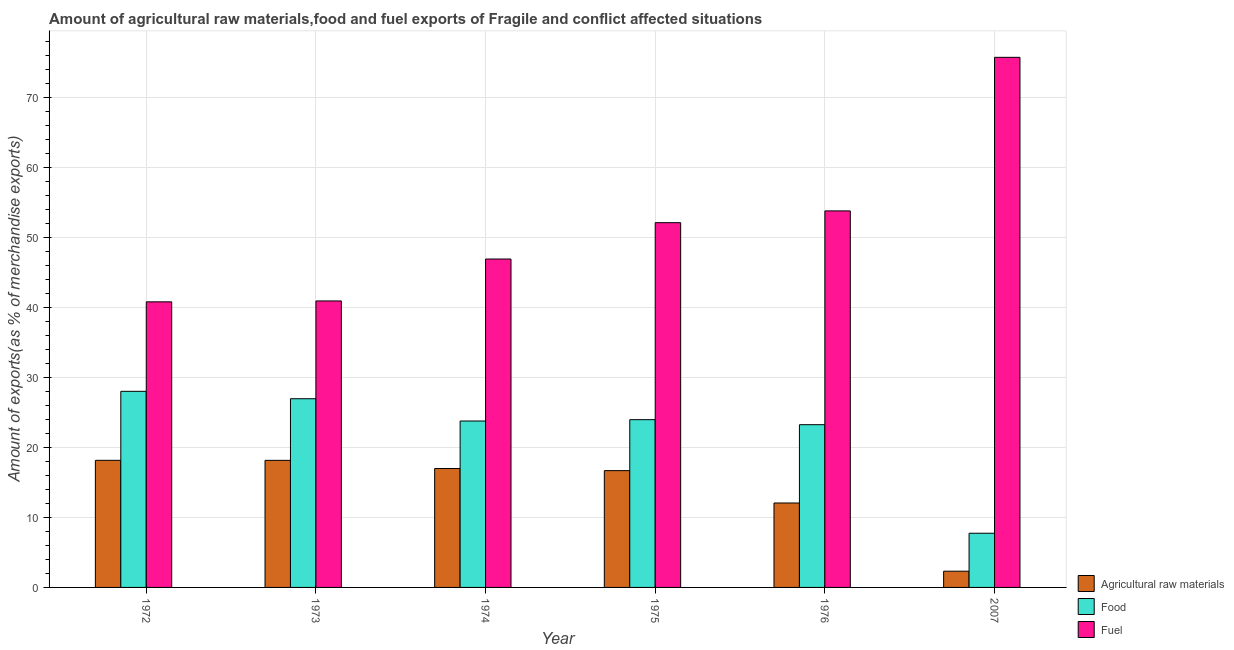How many different coloured bars are there?
Offer a terse response. 3. Are the number of bars on each tick of the X-axis equal?
Make the answer very short. Yes. How many bars are there on the 1st tick from the right?
Your answer should be very brief. 3. What is the label of the 5th group of bars from the left?
Provide a succinct answer. 1976. What is the percentage of fuel exports in 1976?
Provide a succinct answer. 53.82. Across all years, what is the maximum percentage of fuel exports?
Ensure brevity in your answer.  75.77. Across all years, what is the minimum percentage of food exports?
Keep it short and to the point. 7.75. In which year was the percentage of food exports maximum?
Ensure brevity in your answer.  1972. In which year was the percentage of food exports minimum?
Your response must be concise. 2007. What is the total percentage of fuel exports in the graph?
Keep it short and to the point. 310.43. What is the difference between the percentage of fuel exports in 1973 and that in 1975?
Your response must be concise. -11.19. What is the difference between the percentage of food exports in 1972 and the percentage of raw materials exports in 1976?
Provide a short and direct response. 4.77. What is the average percentage of raw materials exports per year?
Keep it short and to the point. 14.07. In the year 1974, what is the difference between the percentage of food exports and percentage of fuel exports?
Offer a very short reply. 0. In how many years, is the percentage of food exports greater than 52 %?
Ensure brevity in your answer.  0. What is the ratio of the percentage of raw materials exports in 1973 to that in 1976?
Provide a succinct answer. 1.51. Is the percentage of raw materials exports in 1975 less than that in 2007?
Your answer should be compact. No. What is the difference between the highest and the second highest percentage of food exports?
Your answer should be very brief. 1.06. What is the difference between the highest and the lowest percentage of food exports?
Your answer should be very brief. 20.29. What does the 1st bar from the left in 1974 represents?
Your response must be concise. Agricultural raw materials. What does the 1st bar from the right in 1973 represents?
Provide a short and direct response. Fuel. Are all the bars in the graph horizontal?
Offer a very short reply. No. Are the values on the major ticks of Y-axis written in scientific E-notation?
Ensure brevity in your answer.  No. Does the graph contain any zero values?
Make the answer very short. No. How many legend labels are there?
Ensure brevity in your answer.  3. How are the legend labels stacked?
Make the answer very short. Vertical. What is the title of the graph?
Ensure brevity in your answer.  Amount of agricultural raw materials,food and fuel exports of Fragile and conflict affected situations. What is the label or title of the X-axis?
Keep it short and to the point. Year. What is the label or title of the Y-axis?
Give a very brief answer. Amount of exports(as % of merchandise exports). What is the Amount of exports(as % of merchandise exports) of Agricultural raw materials in 1972?
Give a very brief answer. 18.17. What is the Amount of exports(as % of merchandise exports) in Food in 1972?
Offer a very short reply. 28.03. What is the Amount of exports(as % of merchandise exports) in Fuel in 1972?
Offer a very short reply. 40.82. What is the Amount of exports(as % of merchandise exports) in Agricultural raw materials in 1973?
Make the answer very short. 18.16. What is the Amount of exports(as % of merchandise exports) in Food in 1973?
Keep it short and to the point. 26.97. What is the Amount of exports(as % of merchandise exports) in Fuel in 1973?
Ensure brevity in your answer.  40.95. What is the Amount of exports(as % of merchandise exports) of Agricultural raw materials in 1974?
Ensure brevity in your answer.  17. What is the Amount of exports(as % of merchandise exports) of Food in 1974?
Provide a short and direct response. 23.79. What is the Amount of exports(as % of merchandise exports) in Fuel in 1974?
Your answer should be compact. 46.94. What is the Amount of exports(as % of merchandise exports) in Agricultural raw materials in 1975?
Provide a succinct answer. 16.69. What is the Amount of exports(as % of merchandise exports) of Food in 1975?
Provide a short and direct response. 23.98. What is the Amount of exports(as % of merchandise exports) in Fuel in 1975?
Give a very brief answer. 52.14. What is the Amount of exports(as % of merchandise exports) in Agricultural raw materials in 1976?
Offer a very short reply. 12.07. What is the Amount of exports(as % of merchandise exports) in Food in 1976?
Give a very brief answer. 23.26. What is the Amount of exports(as % of merchandise exports) in Fuel in 1976?
Offer a very short reply. 53.82. What is the Amount of exports(as % of merchandise exports) in Agricultural raw materials in 2007?
Keep it short and to the point. 2.32. What is the Amount of exports(as % of merchandise exports) in Food in 2007?
Give a very brief answer. 7.75. What is the Amount of exports(as % of merchandise exports) in Fuel in 2007?
Keep it short and to the point. 75.77. Across all years, what is the maximum Amount of exports(as % of merchandise exports) of Agricultural raw materials?
Your response must be concise. 18.17. Across all years, what is the maximum Amount of exports(as % of merchandise exports) in Food?
Provide a succinct answer. 28.03. Across all years, what is the maximum Amount of exports(as % of merchandise exports) in Fuel?
Your answer should be compact. 75.77. Across all years, what is the minimum Amount of exports(as % of merchandise exports) of Agricultural raw materials?
Your answer should be compact. 2.32. Across all years, what is the minimum Amount of exports(as % of merchandise exports) in Food?
Your answer should be very brief. 7.75. Across all years, what is the minimum Amount of exports(as % of merchandise exports) of Fuel?
Ensure brevity in your answer.  40.82. What is the total Amount of exports(as % of merchandise exports) of Agricultural raw materials in the graph?
Your answer should be very brief. 84.41. What is the total Amount of exports(as % of merchandise exports) in Food in the graph?
Your answer should be very brief. 133.78. What is the total Amount of exports(as % of merchandise exports) of Fuel in the graph?
Offer a very short reply. 310.43. What is the difference between the Amount of exports(as % of merchandise exports) in Agricultural raw materials in 1972 and that in 1973?
Your answer should be very brief. 0. What is the difference between the Amount of exports(as % of merchandise exports) in Food in 1972 and that in 1973?
Your response must be concise. 1.06. What is the difference between the Amount of exports(as % of merchandise exports) in Fuel in 1972 and that in 1973?
Offer a very short reply. -0.13. What is the difference between the Amount of exports(as % of merchandise exports) of Agricultural raw materials in 1972 and that in 1974?
Make the answer very short. 1.17. What is the difference between the Amount of exports(as % of merchandise exports) of Food in 1972 and that in 1974?
Keep it short and to the point. 4.24. What is the difference between the Amount of exports(as % of merchandise exports) of Fuel in 1972 and that in 1974?
Offer a very short reply. -6.12. What is the difference between the Amount of exports(as % of merchandise exports) in Agricultural raw materials in 1972 and that in 1975?
Keep it short and to the point. 1.47. What is the difference between the Amount of exports(as % of merchandise exports) of Food in 1972 and that in 1975?
Offer a terse response. 4.05. What is the difference between the Amount of exports(as % of merchandise exports) in Fuel in 1972 and that in 1975?
Keep it short and to the point. -11.32. What is the difference between the Amount of exports(as % of merchandise exports) in Agricultural raw materials in 1972 and that in 1976?
Your answer should be very brief. 6.1. What is the difference between the Amount of exports(as % of merchandise exports) of Food in 1972 and that in 1976?
Ensure brevity in your answer.  4.77. What is the difference between the Amount of exports(as % of merchandise exports) in Fuel in 1972 and that in 1976?
Your response must be concise. -13. What is the difference between the Amount of exports(as % of merchandise exports) of Agricultural raw materials in 1972 and that in 2007?
Your answer should be compact. 15.85. What is the difference between the Amount of exports(as % of merchandise exports) of Food in 1972 and that in 2007?
Offer a very short reply. 20.29. What is the difference between the Amount of exports(as % of merchandise exports) in Fuel in 1972 and that in 2007?
Your response must be concise. -34.95. What is the difference between the Amount of exports(as % of merchandise exports) in Agricultural raw materials in 1973 and that in 1974?
Ensure brevity in your answer.  1.17. What is the difference between the Amount of exports(as % of merchandise exports) of Food in 1973 and that in 1974?
Make the answer very short. 3.19. What is the difference between the Amount of exports(as % of merchandise exports) of Fuel in 1973 and that in 1974?
Offer a very short reply. -5.99. What is the difference between the Amount of exports(as % of merchandise exports) of Agricultural raw materials in 1973 and that in 1975?
Give a very brief answer. 1.47. What is the difference between the Amount of exports(as % of merchandise exports) in Food in 1973 and that in 1975?
Ensure brevity in your answer.  2.99. What is the difference between the Amount of exports(as % of merchandise exports) in Fuel in 1973 and that in 1975?
Make the answer very short. -11.19. What is the difference between the Amount of exports(as % of merchandise exports) of Agricultural raw materials in 1973 and that in 1976?
Give a very brief answer. 6.1. What is the difference between the Amount of exports(as % of merchandise exports) in Food in 1973 and that in 1976?
Offer a terse response. 3.71. What is the difference between the Amount of exports(as % of merchandise exports) of Fuel in 1973 and that in 1976?
Provide a succinct answer. -12.87. What is the difference between the Amount of exports(as % of merchandise exports) of Agricultural raw materials in 1973 and that in 2007?
Give a very brief answer. 15.84. What is the difference between the Amount of exports(as % of merchandise exports) in Food in 1973 and that in 2007?
Provide a succinct answer. 19.23. What is the difference between the Amount of exports(as % of merchandise exports) in Fuel in 1973 and that in 2007?
Offer a terse response. -34.82. What is the difference between the Amount of exports(as % of merchandise exports) of Agricultural raw materials in 1974 and that in 1975?
Ensure brevity in your answer.  0.3. What is the difference between the Amount of exports(as % of merchandise exports) in Food in 1974 and that in 1975?
Your answer should be very brief. -0.19. What is the difference between the Amount of exports(as % of merchandise exports) of Fuel in 1974 and that in 1975?
Keep it short and to the point. -5.2. What is the difference between the Amount of exports(as % of merchandise exports) in Agricultural raw materials in 1974 and that in 1976?
Your answer should be compact. 4.93. What is the difference between the Amount of exports(as % of merchandise exports) of Food in 1974 and that in 1976?
Provide a short and direct response. 0.53. What is the difference between the Amount of exports(as % of merchandise exports) in Fuel in 1974 and that in 1976?
Keep it short and to the point. -6.88. What is the difference between the Amount of exports(as % of merchandise exports) in Agricultural raw materials in 1974 and that in 2007?
Give a very brief answer. 14.68. What is the difference between the Amount of exports(as % of merchandise exports) in Food in 1974 and that in 2007?
Your answer should be very brief. 16.04. What is the difference between the Amount of exports(as % of merchandise exports) of Fuel in 1974 and that in 2007?
Keep it short and to the point. -28.83. What is the difference between the Amount of exports(as % of merchandise exports) in Agricultural raw materials in 1975 and that in 1976?
Make the answer very short. 4.62. What is the difference between the Amount of exports(as % of merchandise exports) in Food in 1975 and that in 1976?
Give a very brief answer. 0.72. What is the difference between the Amount of exports(as % of merchandise exports) in Fuel in 1975 and that in 1976?
Offer a very short reply. -1.68. What is the difference between the Amount of exports(as % of merchandise exports) of Agricultural raw materials in 1975 and that in 2007?
Provide a short and direct response. 14.37. What is the difference between the Amount of exports(as % of merchandise exports) in Food in 1975 and that in 2007?
Give a very brief answer. 16.23. What is the difference between the Amount of exports(as % of merchandise exports) of Fuel in 1975 and that in 2007?
Ensure brevity in your answer.  -23.63. What is the difference between the Amount of exports(as % of merchandise exports) in Agricultural raw materials in 1976 and that in 2007?
Offer a very short reply. 9.75. What is the difference between the Amount of exports(as % of merchandise exports) in Food in 1976 and that in 2007?
Your answer should be compact. 15.52. What is the difference between the Amount of exports(as % of merchandise exports) of Fuel in 1976 and that in 2007?
Keep it short and to the point. -21.95. What is the difference between the Amount of exports(as % of merchandise exports) in Agricultural raw materials in 1972 and the Amount of exports(as % of merchandise exports) in Food in 1973?
Make the answer very short. -8.8. What is the difference between the Amount of exports(as % of merchandise exports) in Agricultural raw materials in 1972 and the Amount of exports(as % of merchandise exports) in Fuel in 1973?
Make the answer very short. -22.78. What is the difference between the Amount of exports(as % of merchandise exports) in Food in 1972 and the Amount of exports(as % of merchandise exports) in Fuel in 1973?
Your answer should be compact. -12.92. What is the difference between the Amount of exports(as % of merchandise exports) of Agricultural raw materials in 1972 and the Amount of exports(as % of merchandise exports) of Food in 1974?
Offer a terse response. -5.62. What is the difference between the Amount of exports(as % of merchandise exports) in Agricultural raw materials in 1972 and the Amount of exports(as % of merchandise exports) in Fuel in 1974?
Offer a very short reply. -28.77. What is the difference between the Amount of exports(as % of merchandise exports) of Food in 1972 and the Amount of exports(as % of merchandise exports) of Fuel in 1974?
Your response must be concise. -18.91. What is the difference between the Amount of exports(as % of merchandise exports) of Agricultural raw materials in 1972 and the Amount of exports(as % of merchandise exports) of Food in 1975?
Your response must be concise. -5.81. What is the difference between the Amount of exports(as % of merchandise exports) of Agricultural raw materials in 1972 and the Amount of exports(as % of merchandise exports) of Fuel in 1975?
Your answer should be very brief. -33.97. What is the difference between the Amount of exports(as % of merchandise exports) in Food in 1972 and the Amount of exports(as % of merchandise exports) in Fuel in 1975?
Provide a succinct answer. -24.1. What is the difference between the Amount of exports(as % of merchandise exports) in Agricultural raw materials in 1972 and the Amount of exports(as % of merchandise exports) in Food in 1976?
Offer a very short reply. -5.09. What is the difference between the Amount of exports(as % of merchandise exports) of Agricultural raw materials in 1972 and the Amount of exports(as % of merchandise exports) of Fuel in 1976?
Make the answer very short. -35.65. What is the difference between the Amount of exports(as % of merchandise exports) of Food in 1972 and the Amount of exports(as % of merchandise exports) of Fuel in 1976?
Provide a short and direct response. -25.79. What is the difference between the Amount of exports(as % of merchandise exports) of Agricultural raw materials in 1972 and the Amount of exports(as % of merchandise exports) of Food in 2007?
Your response must be concise. 10.42. What is the difference between the Amount of exports(as % of merchandise exports) of Agricultural raw materials in 1972 and the Amount of exports(as % of merchandise exports) of Fuel in 2007?
Your response must be concise. -57.6. What is the difference between the Amount of exports(as % of merchandise exports) in Food in 1972 and the Amount of exports(as % of merchandise exports) in Fuel in 2007?
Provide a short and direct response. -47.74. What is the difference between the Amount of exports(as % of merchandise exports) of Agricultural raw materials in 1973 and the Amount of exports(as % of merchandise exports) of Food in 1974?
Offer a very short reply. -5.62. What is the difference between the Amount of exports(as % of merchandise exports) in Agricultural raw materials in 1973 and the Amount of exports(as % of merchandise exports) in Fuel in 1974?
Provide a short and direct response. -28.78. What is the difference between the Amount of exports(as % of merchandise exports) in Food in 1973 and the Amount of exports(as % of merchandise exports) in Fuel in 1974?
Your answer should be very brief. -19.97. What is the difference between the Amount of exports(as % of merchandise exports) of Agricultural raw materials in 1973 and the Amount of exports(as % of merchandise exports) of Food in 1975?
Offer a terse response. -5.81. What is the difference between the Amount of exports(as % of merchandise exports) in Agricultural raw materials in 1973 and the Amount of exports(as % of merchandise exports) in Fuel in 1975?
Offer a terse response. -33.97. What is the difference between the Amount of exports(as % of merchandise exports) in Food in 1973 and the Amount of exports(as % of merchandise exports) in Fuel in 1975?
Your response must be concise. -25.16. What is the difference between the Amount of exports(as % of merchandise exports) in Agricultural raw materials in 1973 and the Amount of exports(as % of merchandise exports) in Food in 1976?
Ensure brevity in your answer.  -5.1. What is the difference between the Amount of exports(as % of merchandise exports) of Agricultural raw materials in 1973 and the Amount of exports(as % of merchandise exports) of Fuel in 1976?
Make the answer very short. -35.66. What is the difference between the Amount of exports(as % of merchandise exports) in Food in 1973 and the Amount of exports(as % of merchandise exports) in Fuel in 1976?
Your response must be concise. -26.85. What is the difference between the Amount of exports(as % of merchandise exports) of Agricultural raw materials in 1973 and the Amount of exports(as % of merchandise exports) of Food in 2007?
Provide a succinct answer. 10.42. What is the difference between the Amount of exports(as % of merchandise exports) of Agricultural raw materials in 1973 and the Amount of exports(as % of merchandise exports) of Fuel in 2007?
Keep it short and to the point. -57.61. What is the difference between the Amount of exports(as % of merchandise exports) of Food in 1973 and the Amount of exports(as % of merchandise exports) of Fuel in 2007?
Your answer should be compact. -48.8. What is the difference between the Amount of exports(as % of merchandise exports) of Agricultural raw materials in 1974 and the Amount of exports(as % of merchandise exports) of Food in 1975?
Give a very brief answer. -6.98. What is the difference between the Amount of exports(as % of merchandise exports) of Agricultural raw materials in 1974 and the Amount of exports(as % of merchandise exports) of Fuel in 1975?
Your response must be concise. -35.14. What is the difference between the Amount of exports(as % of merchandise exports) of Food in 1974 and the Amount of exports(as % of merchandise exports) of Fuel in 1975?
Keep it short and to the point. -28.35. What is the difference between the Amount of exports(as % of merchandise exports) in Agricultural raw materials in 1974 and the Amount of exports(as % of merchandise exports) in Food in 1976?
Provide a succinct answer. -6.26. What is the difference between the Amount of exports(as % of merchandise exports) in Agricultural raw materials in 1974 and the Amount of exports(as % of merchandise exports) in Fuel in 1976?
Make the answer very short. -36.82. What is the difference between the Amount of exports(as % of merchandise exports) in Food in 1974 and the Amount of exports(as % of merchandise exports) in Fuel in 1976?
Make the answer very short. -30.03. What is the difference between the Amount of exports(as % of merchandise exports) in Agricultural raw materials in 1974 and the Amount of exports(as % of merchandise exports) in Food in 2007?
Your response must be concise. 9.25. What is the difference between the Amount of exports(as % of merchandise exports) of Agricultural raw materials in 1974 and the Amount of exports(as % of merchandise exports) of Fuel in 2007?
Make the answer very short. -58.77. What is the difference between the Amount of exports(as % of merchandise exports) of Food in 1974 and the Amount of exports(as % of merchandise exports) of Fuel in 2007?
Offer a very short reply. -51.98. What is the difference between the Amount of exports(as % of merchandise exports) of Agricultural raw materials in 1975 and the Amount of exports(as % of merchandise exports) of Food in 1976?
Provide a succinct answer. -6.57. What is the difference between the Amount of exports(as % of merchandise exports) of Agricultural raw materials in 1975 and the Amount of exports(as % of merchandise exports) of Fuel in 1976?
Give a very brief answer. -37.13. What is the difference between the Amount of exports(as % of merchandise exports) in Food in 1975 and the Amount of exports(as % of merchandise exports) in Fuel in 1976?
Keep it short and to the point. -29.84. What is the difference between the Amount of exports(as % of merchandise exports) in Agricultural raw materials in 1975 and the Amount of exports(as % of merchandise exports) in Food in 2007?
Your answer should be compact. 8.95. What is the difference between the Amount of exports(as % of merchandise exports) of Agricultural raw materials in 1975 and the Amount of exports(as % of merchandise exports) of Fuel in 2007?
Make the answer very short. -59.08. What is the difference between the Amount of exports(as % of merchandise exports) in Food in 1975 and the Amount of exports(as % of merchandise exports) in Fuel in 2007?
Your answer should be very brief. -51.79. What is the difference between the Amount of exports(as % of merchandise exports) in Agricultural raw materials in 1976 and the Amount of exports(as % of merchandise exports) in Food in 2007?
Your answer should be compact. 4.32. What is the difference between the Amount of exports(as % of merchandise exports) in Agricultural raw materials in 1976 and the Amount of exports(as % of merchandise exports) in Fuel in 2007?
Your response must be concise. -63.7. What is the difference between the Amount of exports(as % of merchandise exports) in Food in 1976 and the Amount of exports(as % of merchandise exports) in Fuel in 2007?
Offer a very short reply. -52.51. What is the average Amount of exports(as % of merchandise exports) of Agricultural raw materials per year?
Your answer should be very brief. 14.07. What is the average Amount of exports(as % of merchandise exports) of Food per year?
Ensure brevity in your answer.  22.3. What is the average Amount of exports(as % of merchandise exports) in Fuel per year?
Provide a short and direct response. 51.74. In the year 1972, what is the difference between the Amount of exports(as % of merchandise exports) in Agricultural raw materials and Amount of exports(as % of merchandise exports) in Food?
Offer a very short reply. -9.86. In the year 1972, what is the difference between the Amount of exports(as % of merchandise exports) of Agricultural raw materials and Amount of exports(as % of merchandise exports) of Fuel?
Offer a very short reply. -22.65. In the year 1972, what is the difference between the Amount of exports(as % of merchandise exports) of Food and Amount of exports(as % of merchandise exports) of Fuel?
Make the answer very short. -12.79. In the year 1973, what is the difference between the Amount of exports(as % of merchandise exports) of Agricultural raw materials and Amount of exports(as % of merchandise exports) of Food?
Give a very brief answer. -8.81. In the year 1973, what is the difference between the Amount of exports(as % of merchandise exports) in Agricultural raw materials and Amount of exports(as % of merchandise exports) in Fuel?
Your response must be concise. -22.78. In the year 1973, what is the difference between the Amount of exports(as % of merchandise exports) in Food and Amount of exports(as % of merchandise exports) in Fuel?
Give a very brief answer. -13.98. In the year 1974, what is the difference between the Amount of exports(as % of merchandise exports) of Agricultural raw materials and Amount of exports(as % of merchandise exports) of Food?
Offer a very short reply. -6.79. In the year 1974, what is the difference between the Amount of exports(as % of merchandise exports) in Agricultural raw materials and Amount of exports(as % of merchandise exports) in Fuel?
Your answer should be compact. -29.94. In the year 1974, what is the difference between the Amount of exports(as % of merchandise exports) in Food and Amount of exports(as % of merchandise exports) in Fuel?
Keep it short and to the point. -23.15. In the year 1975, what is the difference between the Amount of exports(as % of merchandise exports) in Agricultural raw materials and Amount of exports(as % of merchandise exports) in Food?
Ensure brevity in your answer.  -7.29. In the year 1975, what is the difference between the Amount of exports(as % of merchandise exports) of Agricultural raw materials and Amount of exports(as % of merchandise exports) of Fuel?
Give a very brief answer. -35.44. In the year 1975, what is the difference between the Amount of exports(as % of merchandise exports) of Food and Amount of exports(as % of merchandise exports) of Fuel?
Your answer should be very brief. -28.16. In the year 1976, what is the difference between the Amount of exports(as % of merchandise exports) in Agricultural raw materials and Amount of exports(as % of merchandise exports) in Food?
Provide a short and direct response. -11.19. In the year 1976, what is the difference between the Amount of exports(as % of merchandise exports) of Agricultural raw materials and Amount of exports(as % of merchandise exports) of Fuel?
Provide a short and direct response. -41.75. In the year 1976, what is the difference between the Amount of exports(as % of merchandise exports) in Food and Amount of exports(as % of merchandise exports) in Fuel?
Offer a very short reply. -30.56. In the year 2007, what is the difference between the Amount of exports(as % of merchandise exports) of Agricultural raw materials and Amount of exports(as % of merchandise exports) of Food?
Offer a terse response. -5.42. In the year 2007, what is the difference between the Amount of exports(as % of merchandise exports) in Agricultural raw materials and Amount of exports(as % of merchandise exports) in Fuel?
Provide a short and direct response. -73.45. In the year 2007, what is the difference between the Amount of exports(as % of merchandise exports) in Food and Amount of exports(as % of merchandise exports) in Fuel?
Your answer should be very brief. -68.02. What is the ratio of the Amount of exports(as % of merchandise exports) of Food in 1972 to that in 1973?
Offer a terse response. 1.04. What is the ratio of the Amount of exports(as % of merchandise exports) of Agricultural raw materials in 1972 to that in 1974?
Your response must be concise. 1.07. What is the ratio of the Amount of exports(as % of merchandise exports) of Food in 1972 to that in 1974?
Offer a terse response. 1.18. What is the ratio of the Amount of exports(as % of merchandise exports) in Fuel in 1972 to that in 1974?
Give a very brief answer. 0.87. What is the ratio of the Amount of exports(as % of merchandise exports) of Agricultural raw materials in 1972 to that in 1975?
Make the answer very short. 1.09. What is the ratio of the Amount of exports(as % of merchandise exports) in Food in 1972 to that in 1975?
Your answer should be very brief. 1.17. What is the ratio of the Amount of exports(as % of merchandise exports) of Fuel in 1972 to that in 1975?
Provide a succinct answer. 0.78. What is the ratio of the Amount of exports(as % of merchandise exports) of Agricultural raw materials in 1972 to that in 1976?
Make the answer very short. 1.51. What is the ratio of the Amount of exports(as % of merchandise exports) in Food in 1972 to that in 1976?
Provide a succinct answer. 1.21. What is the ratio of the Amount of exports(as % of merchandise exports) of Fuel in 1972 to that in 1976?
Provide a short and direct response. 0.76. What is the ratio of the Amount of exports(as % of merchandise exports) in Agricultural raw materials in 1972 to that in 2007?
Your answer should be very brief. 7.83. What is the ratio of the Amount of exports(as % of merchandise exports) in Food in 1972 to that in 2007?
Offer a very short reply. 3.62. What is the ratio of the Amount of exports(as % of merchandise exports) of Fuel in 1972 to that in 2007?
Provide a short and direct response. 0.54. What is the ratio of the Amount of exports(as % of merchandise exports) of Agricultural raw materials in 1973 to that in 1974?
Your response must be concise. 1.07. What is the ratio of the Amount of exports(as % of merchandise exports) in Food in 1973 to that in 1974?
Provide a short and direct response. 1.13. What is the ratio of the Amount of exports(as % of merchandise exports) of Fuel in 1973 to that in 1974?
Offer a very short reply. 0.87. What is the ratio of the Amount of exports(as % of merchandise exports) of Agricultural raw materials in 1973 to that in 1975?
Your answer should be very brief. 1.09. What is the ratio of the Amount of exports(as % of merchandise exports) in Food in 1973 to that in 1975?
Ensure brevity in your answer.  1.12. What is the ratio of the Amount of exports(as % of merchandise exports) of Fuel in 1973 to that in 1975?
Ensure brevity in your answer.  0.79. What is the ratio of the Amount of exports(as % of merchandise exports) of Agricultural raw materials in 1973 to that in 1976?
Provide a succinct answer. 1.5. What is the ratio of the Amount of exports(as % of merchandise exports) of Food in 1973 to that in 1976?
Keep it short and to the point. 1.16. What is the ratio of the Amount of exports(as % of merchandise exports) of Fuel in 1973 to that in 1976?
Make the answer very short. 0.76. What is the ratio of the Amount of exports(as % of merchandise exports) of Agricultural raw materials in 1973 to that in 2007?
Make the answer very short. 7.83. What is the ratio of the Amount of exports(as % of merchandise exports) of Food in 1973 to that in 2007?
Offer a terse response. 3.48. What is the ratio of the Amount of exports(as % of merchandise exports) in Fuel in 1973 to that in 2007?
Your answer should be very brief. 0.54. What is the ratio of the Amount of exports(as % of merchandise exports) of Agricultural raw materials in 1974 to that in 1975?
Offer a terse response. 1.02. What is the ratio of the Amount of exports(as % of merchandise exports) of Food in 1974 to that in 1975?
Make the answer very short. 0.99. What is the ratio of the Amount of exports(as % of merchandise exports) of Fuel in 1974 to that in 1975?
Your answer should be compact. 0.9. What is the ratio of the Amount of exports(as % of merchandise exports) of Agricultural raw materials in 1974 to that in 1976?
Provide a short and direct response. 1.41. What is the ratio of the Amount of exports(as % of merchandise exports) in Food in 1974 to that in 1976?
Provide a short and direct response. 1.02. What is the ratio of the Amount of exports(as % of merchandise exports) in Fuel in 1974 to that in 1976?
Give a very brief answer. 0.87. What is the ratio of the Amount of exports(as % of merchandise exports) of Agricultural raw materials in 1974 to that in 2007?
Offer a terse response. 7.32. What is the ratio of the Amount of exports(as % of merchandise exports) of Food in 1974 to that in 2007?
Provide a short and direct response. 3.07. What is the ratio of the Amount of exports(as % of merchandise exports) in Fuel in 1974 to that in 2007?
Provide a succinct answer. 0.62. What is the ratio of the Amount of exports(as % of merchandise exports) in Agricultural raw materials in 1975 to that in 1976?
Provide a short and direct response. 1.38. What is the ratio of the Amount of exports(as % of merchandise exports) in Food in 1975 to that in 1976?
Provide a succinct answer. 1.03. What is the ratio of the Amount of exports(as % of merchandise exports) of Fuel in 1975 to that in 1976?
Offer a very short reply. 0.97. What is the ratio of the Amount of exports(as % of merchandise exports) of Agricultural raw materials in 1975 to that in 2007?
Keep it short and to the point. 7.19. What is the ratio of the Amount of exports(as % of merchandise exports) of Food in 1975 to that in 2007?
Your answer should be very brief. 3.1. What is the ratio of the Amount of exports(as % of merchandise exports) in Fuel in 1975 to that in 2007?
Provide a succinct answer. 0.69. What is the ratio of the Amount of exports(as % of merchandise exports) in Agricultural raw materials in 1976 to that in 2007?
Make the answer very short. 5.2. What is the ratio of the Amount of exports(as % of merchandise exports) of Food in 1976 to that in 2007?
Ensure brevity in your answer.  3. What is the ratio of the Amount of exports(as % of merchandise exports) of Fuel in 1976 to that in 2007?
Offer a terse response. 0.71. What is the difference between the highest and the second highest Amount of exports(as % of merchandise exports) in Agricultural raw materials?
Offer a very short reply. 0. What is the difference between the highest and the second highest Amount of exports(as % of merchandise exports) of Food?
Your response must be concise. 1.06. What is the difference between the highest and the second highest Amount of exports(as % of merchandise exports) of Fuel?
Offer a very short reply. 21.95. What is the difference between the highest and the lowest Amount of exports(as % of merchandise exports) in Agricultural raw materials?
Offer a terse response. 15.85. What is the difference between the highest and the lowest Amount of exports(as % of merchandise exports) of Food?
Offer a very short reply. 20.29. What is the difference between the highest and the lowest Amount of exports(as % of merchandise exports) of Fuel?
Keep it short and to the point. 34.95. 